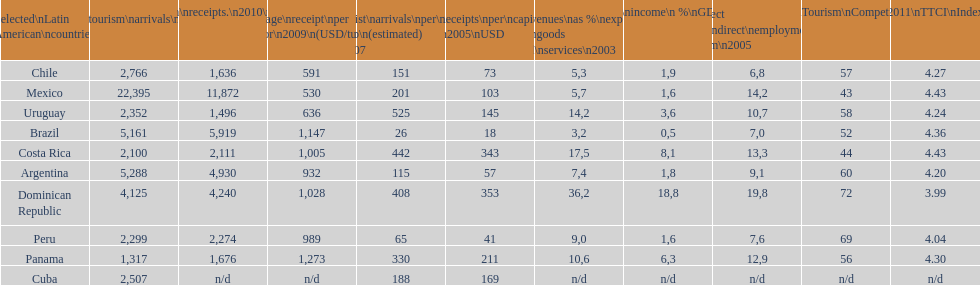Would you mind parsing the complete table? {'header': ['Selected\\nLatin American\\ncountries', 'Internl.\\ntourism\\narrivals\\n2010\\n(x 1000)', 'Internl.\\ntourism\\nreceipts.\\n2010\\n(USD\\n(x1000)', 'Average\\nreceipt\\nper visitor\\n2009\\n(USD/turista)', 'Tourist\\narrivals\\nper\\n1000 inhab\\n(estimated) \\n2007', 'Receipts\\nper\\ncapita \\n2005\\nUSD', 'Revenues\\nas\xa0%\\nexports of\\ngoods and\\nservices\\n2003', 'Tourism\\nincome\\n\xa0%\\nGDP\\n2003', '% Direct and\\nindirect\\nemployment\\nin tourism\\n2005', 'World\\nranking\\nTourism\\nCompetitiv.\\nTTCI\\n2011', '2011\\nTTCI\\nIndex'], 'rows': [['Chile', '2,766', '1,636', '591', '151', '73', '5,3', '1,9', '6,8', '57', '4.27'], ['Mexico', '22,395', '11,872', '530', '201', '103', '5,7', '1,6', '14,2', '43', '4.43'], ['Uruguay', '2,352', '1,496', '636', '525', '145', '14,2', '3,6', '10,7', '58', '4.24'], ['Brazil', '5,161', '5,919', '1,147', '26', '18', '3,2', '0,5', '7,0', '52', '4.36'], ['Costa Rica', '2,100', '2,111', '1,005', '442', '343', '17,5', '8,1', '13,3', '44', '4.43'], ['Argentina', '5,288', '4,930', '932', '115', '57', '7,4', '1,8', '9,1', '60', '4.20'], ['Dominican Republic', '4,125', '4,240', '1,028', '408', '353', '36,2', '18,8', '19,8', '72', '3.99'], ['Peru', '2,299', '2,274', '989', '65', '41', '9,0', '1,6', '7,6', '69', '4.04'], ['Panama', '1,317', '1,676', '1,273', '330', '211', '10,6', '6,3', '12,9', '56', '4.30'], ['Cuba', '2,507', 'n/d', 'n/d', '188', '169', 'n/d', 'n/d', 'n/d', 'n/d', 'n/d']]} Which nation holds the top position across numerous categories? Dominican Republic. 